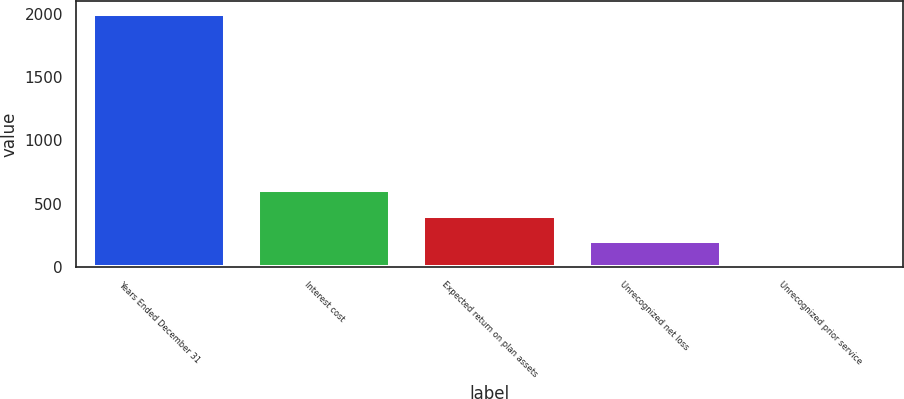Convert chart to OTSL. <chart><loc_0><loc_0><loc_500><loc_500><bar_chart><fcel>Years Ended December 31<fcel>Interest cost<fcel>Expected return on plan assets<fcel>Unrecognized net loss<fcel>Unrecognized prior service<nl><fcel>2004<fcel>604<fcel>404<fcel>204<fcel>4<nl></chart> 